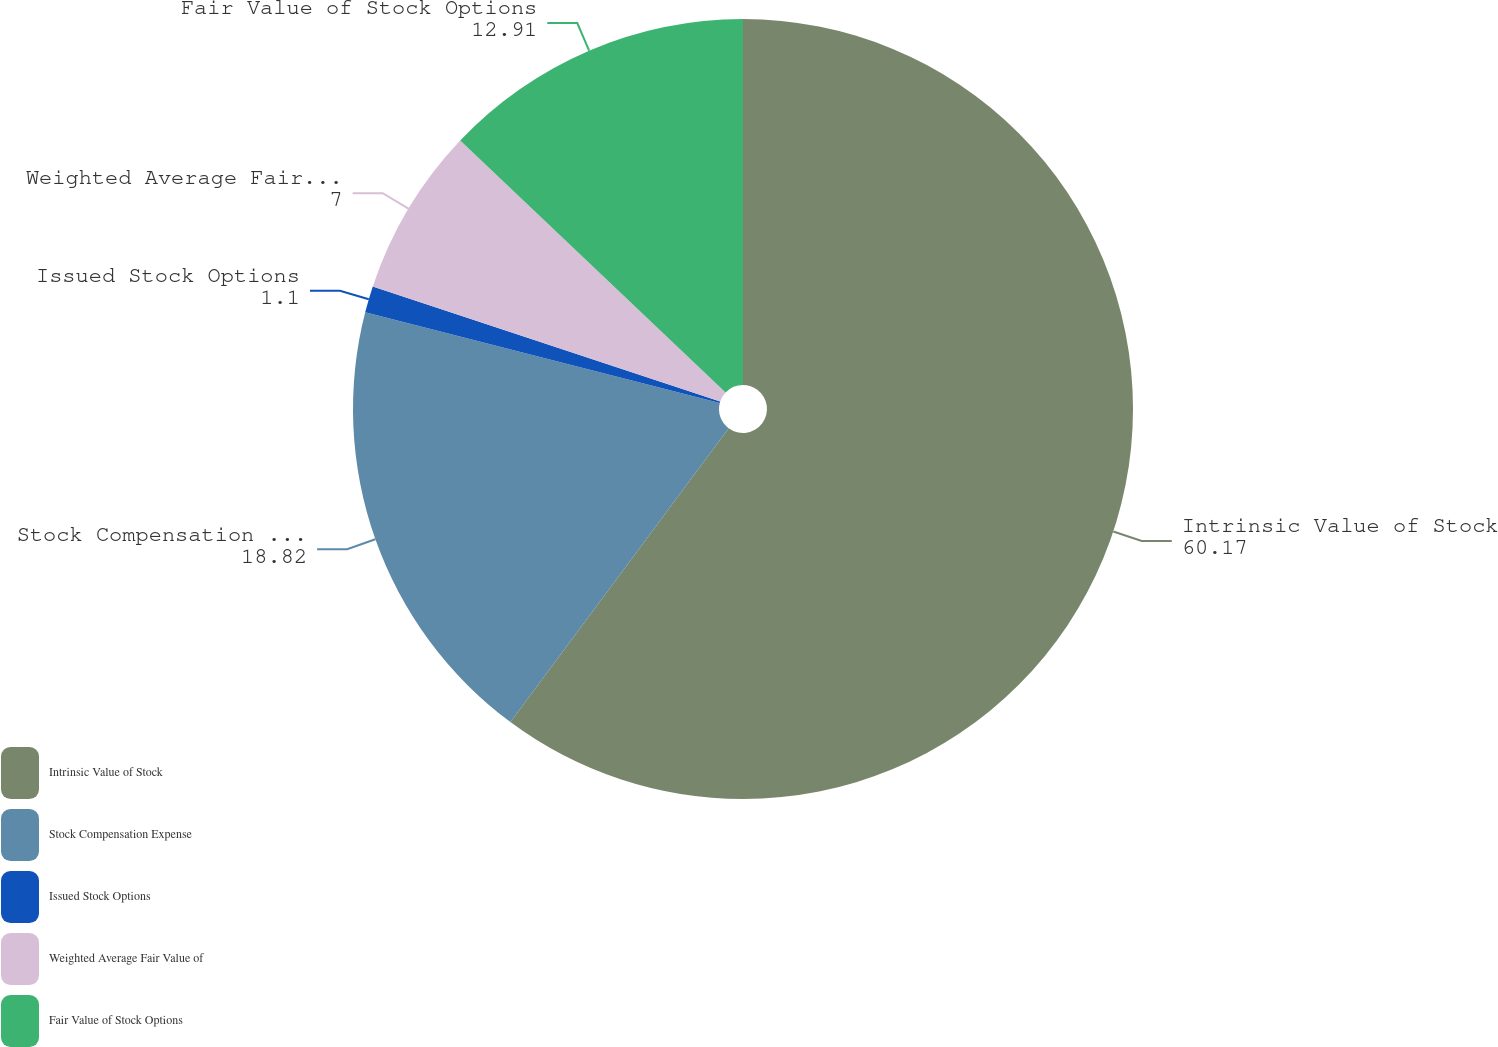Convert chart to OTSL. <chart><loc_0><loc_0><loc_500><loc_500><pie_chart><fcel>Intrinsic Value of Stock<fcel>Stock Compensation Expense<fcel>Issued Stock Options<fcel>Weighted Average Fair Value of<fcel>Fair Value of Stock Options<nl><fcel>60.17%<fcel>18.82%<fcel>1.1%<fcel>7.0%<fcel>12.91%<nl></chart> 